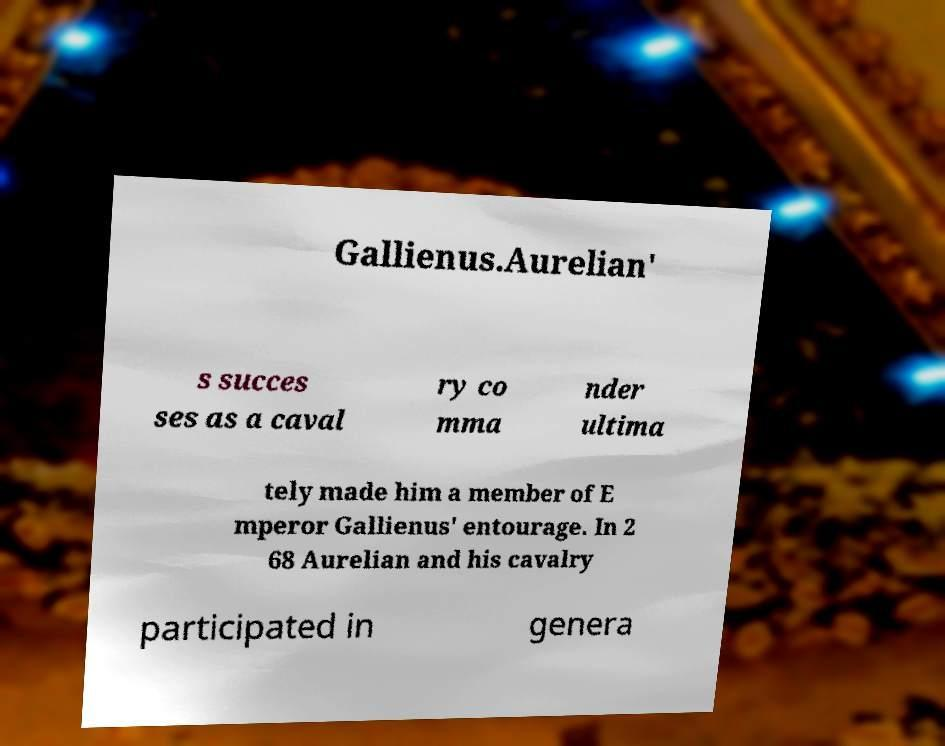Please identify and transcribe the text found in this image. Gallienus.Aurelian' s succes ses as a caval ry co mma nder ultima tely made him a member of E mperor Gallienus' entourage. In 2 68 Aurelian and his cavalry participated in genera 